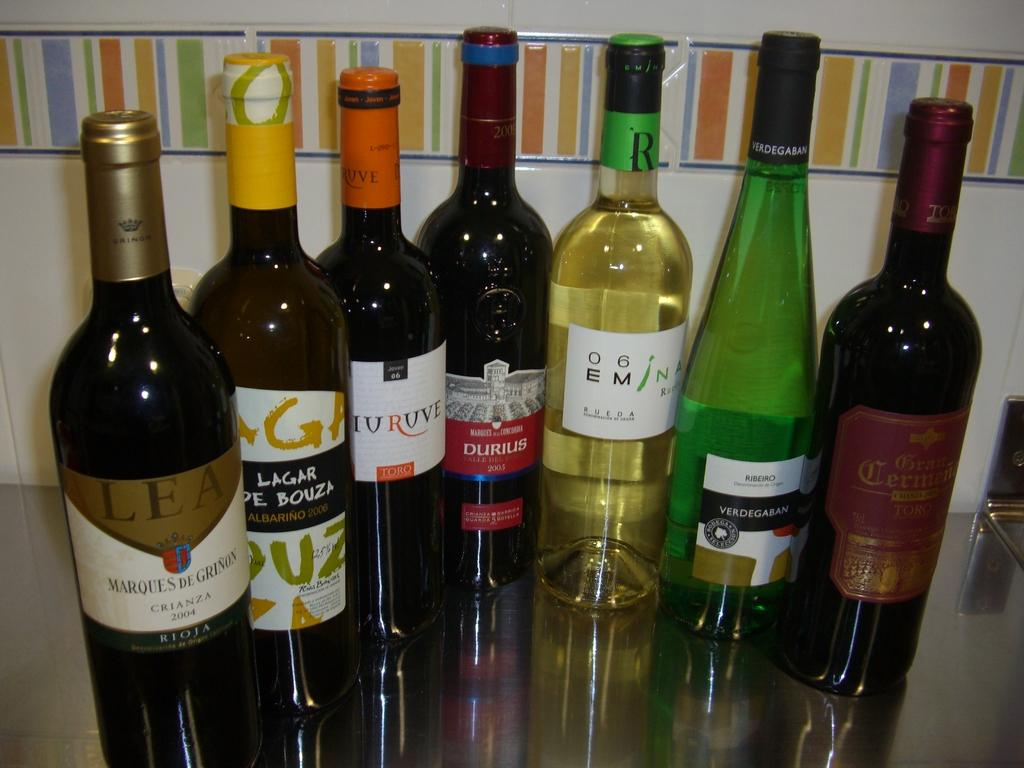Provide a one-sentence caption for the provided image. Some bottles of wine with titles like DURIUS. 